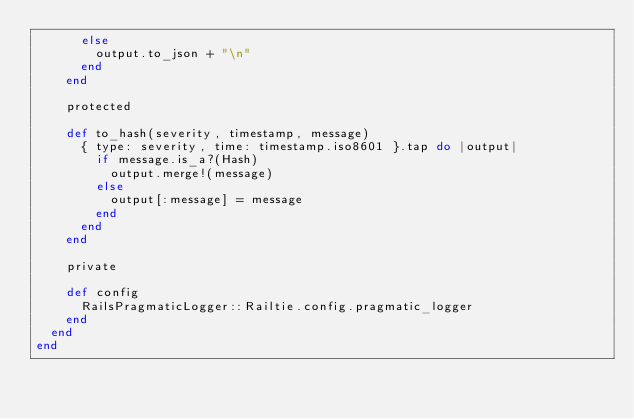Convert code to text. <code><loc_0><loc_0><loc_500><loc_500><_Ruby_>      else
        output.to_json + "\n"
      end
    end

    protected

    def to_hash(severity, timestamp, message)
      { type: severity, time: timestamp.iso8601 }.tap do |output|
        if message.is_a?(Hash)
          output.merge!(message)
        else
          output[:message] = message
        end
      end
    end

    private

    def config
      RailsPragmaticLogger::Railtie.config.pragmatic_logger
    end
  end
end
</code> 